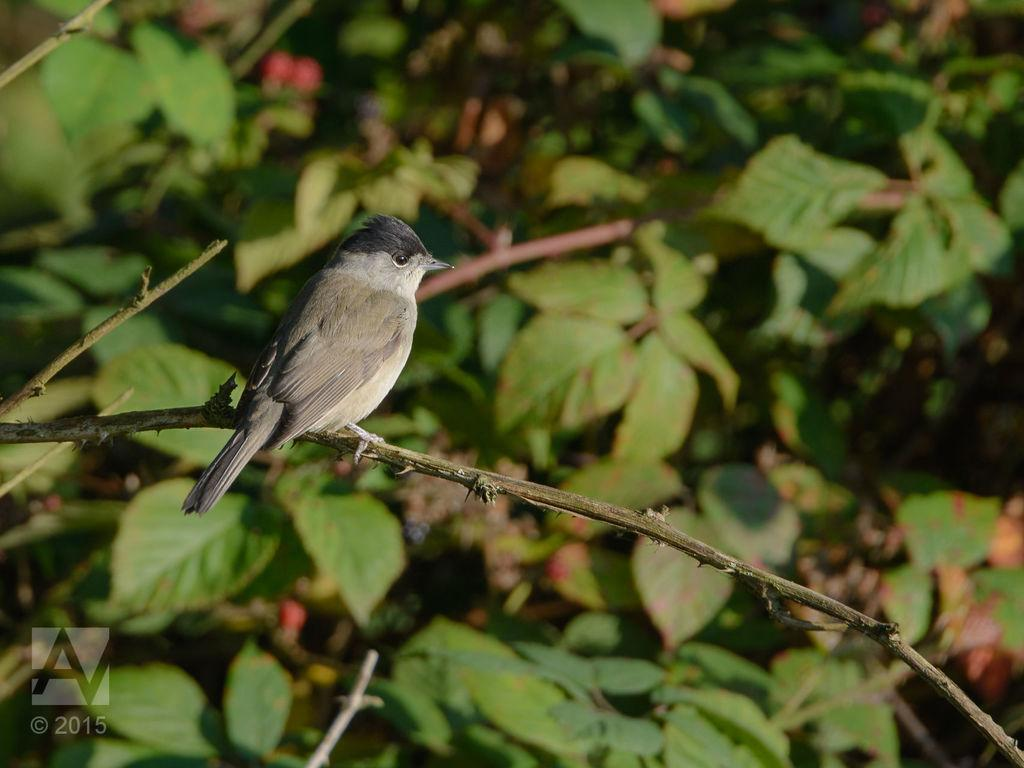What type of animal can be seen in the image? There is a bird in the image. Where is the bird located in the image? The bird is sitting on a stem. What else can be seen in the image besides the bird? Leaves are visible in the image. How would you describe the background of the image? The background of the image is slightly blurred. What is the bird's digestion process like in the image? The image does not provide information about the bird's digestion process. How does the bird sort the leaves in the image? The image does not show the bird sorting leaves; it is simply sitting on a stem. 